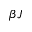Convert formula to latex. <formula><loc_0><loc_0><loc_500><loc_500>\beta J</formula> 